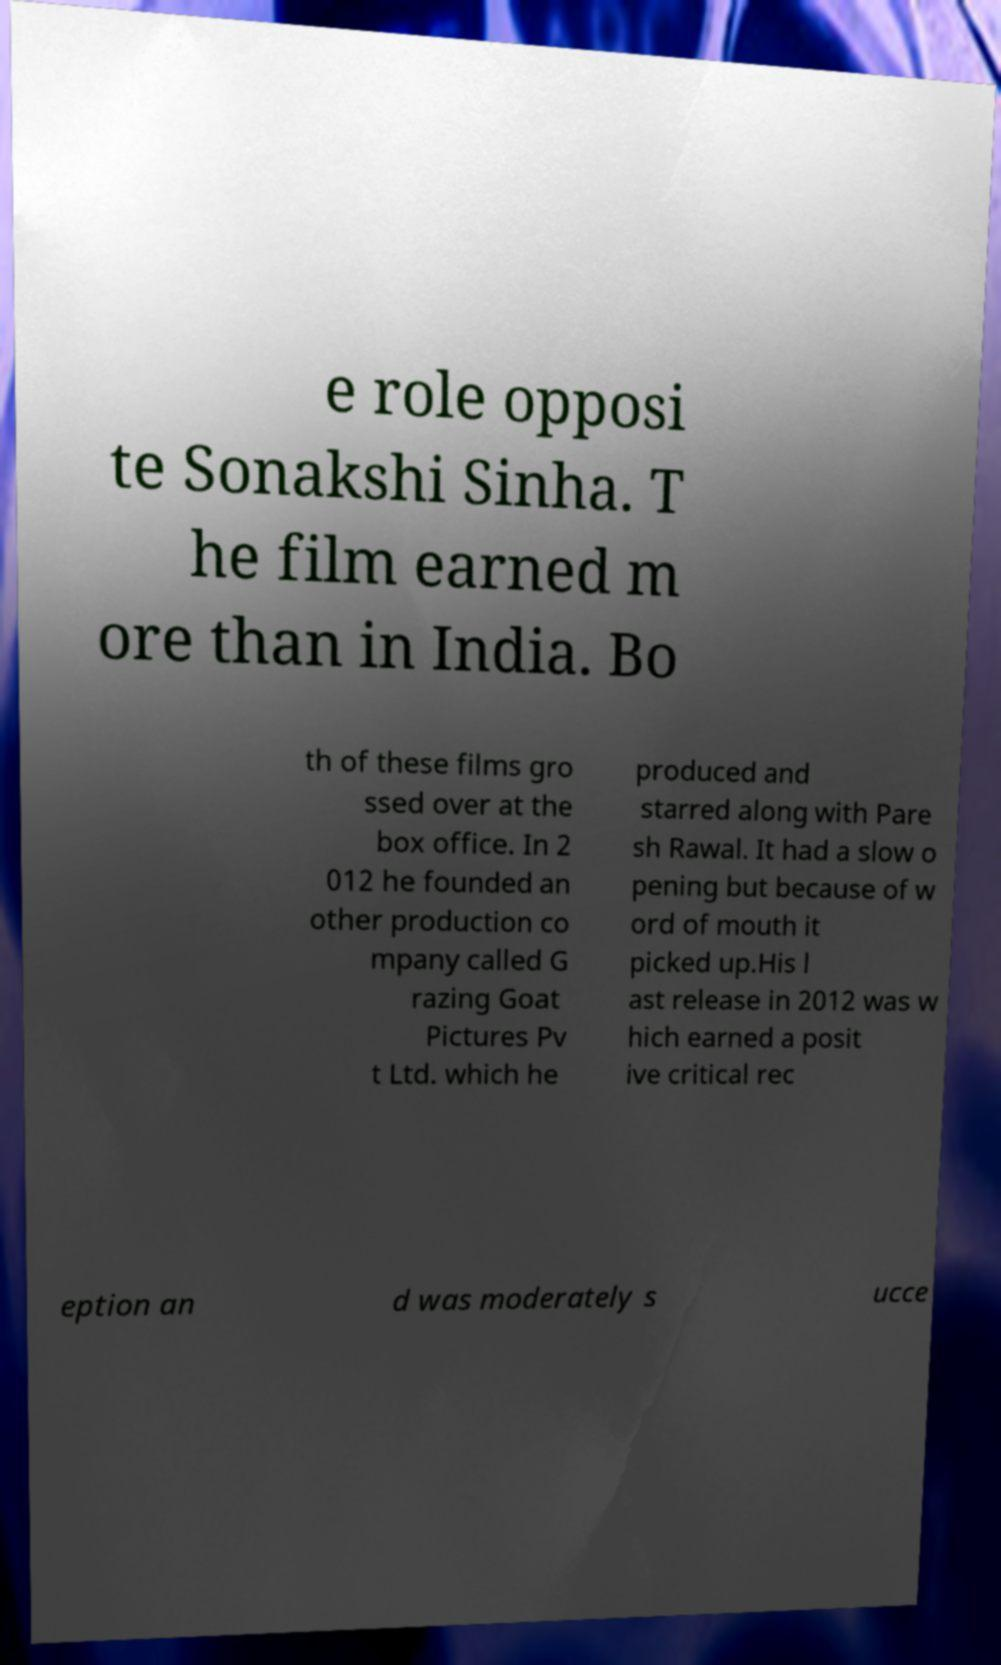What messages or text are displayed in this image? I need them in a readable, typed format. e role opposi te Sonakshi Sinha. T he film earned m ore than in India. Bo th of these films gro ssed over at the box office. In 2 012 he founded an other production co mpany called G razing Goat Pictures Pv t Ltd. which he produced and starred along with Pare sh Rawal. It had a slow o pening but because of w ord of mouth it picked up.His l ast release in 2012 was w hich earned a posit ive critical rec eption an d was moderately s ucce 